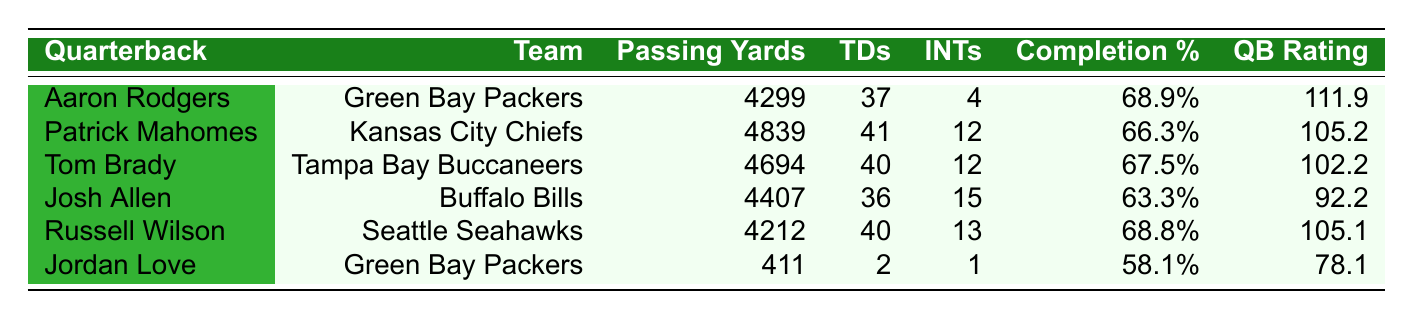What is the highest number of passing yards among the quarterbacks listed? The table shows the passing yards for each quarterback. By checking each value, I see that Patrick Mahomes has the highest at 4839 yards.
Answer: 4839 Which quarterback has the lowest completion percentage? Looking at the completion percentages, I find that Jordan Love has the lowest at 58.1%.
Answer: 58.1% How many touchdowns did Aaron Rodgers throw? The table indicates that Aaron Rodgers threw 37 touchdowns.
Answer: 37 What is the difference in passing yards between Tom Brady and Josh Allen? Tom Brady has 4694 passing yards, while Josh Allen has 4407 yards. The difference is 4694 - 4407 = 287 yards.
Answer: 287 Is it true that Russell Wilson has more interceptions than Aaron Rodgers? According to the table, Russell Wilson has 13 interceptions while Aaron Rodgers has 4. Therefore, it is true that Russell Wilson has more interceptions than Aaron Rodgers.
Answer: Yes Which quarterback has the highest QB rating out of all the players listed? Looking through the QB ratings, the highest rating is 111.9 for Aaron Rodgers.
Answer: 111.9 What is the average number of touchdowns thrown by the quarterbacks? The total touchdowns are (37 + 41 + 40 + 36 + 40 + 2) = 196. There are 6 quarterbacks, so the average is 196 / 6 ≈ 32.67.
Answer: 32.67 Who are the quarterbacks from the Green Bay Packers and what are their passing yards? The table shows two quarterbacks from the Packers: Aaron Rodgers with 4299 passing yards and Jordan Love with 411 passing yards.
Answer: Aaron Rodgers: 4299, Jordan Love: 411 If we combine the passing yards of both Packers' quarterbacks, what is the total? The passing yards for Aaron Rodgers are 4299 and for Jordan Love are 411. Adding these gives a total of 4299 + 411 = 4710.
Answer: 4710 Which quarterback has the second highest number of touchdowns? By examining the touchdown counts, Patrick Mahomes leads with 41, followed by Tom Brady with 40 touchdowns, making him second.
Answer: Tom Brady 